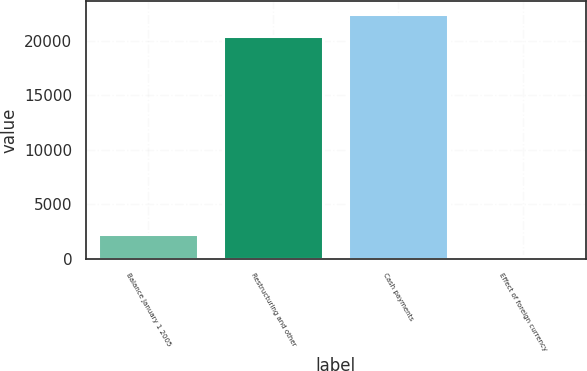<chart> <loc_0><loc_0><loc_500><loc_500><bar_chart><fcel>Balance January 1 2005<fcel>Restructuring and other<fcel>Cash payments<fcel>Effect of foreign currency<nl><fcel>2260.2<fcel>20442<fcel>22478.2<fcel>224<nl></chart> 